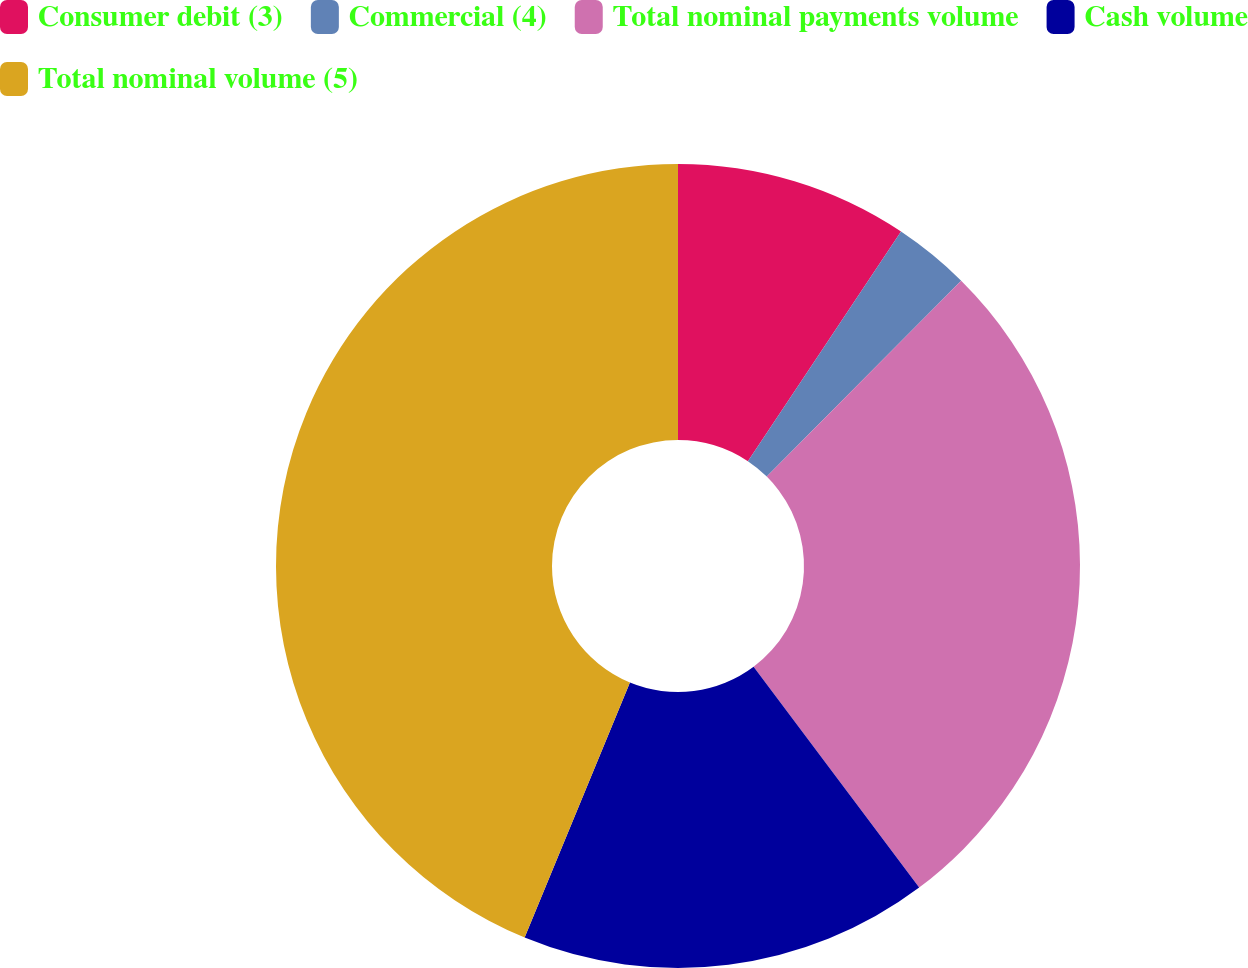Convert chart to OTSL. <chart><loc_0><loc_0><loc_500><loc_500><pie_chart><fcel>Consumer debit (3)<fcel>Commercial (4)<fcel>Total nominal payments volume<fcel>Cash volume<fcel>Total nominal volume (5)<nl><fcel>9.36%<fcel>3.08%<fcel>27.32%<fcel>16.47%<fcel>43.77%<nl></chart> 